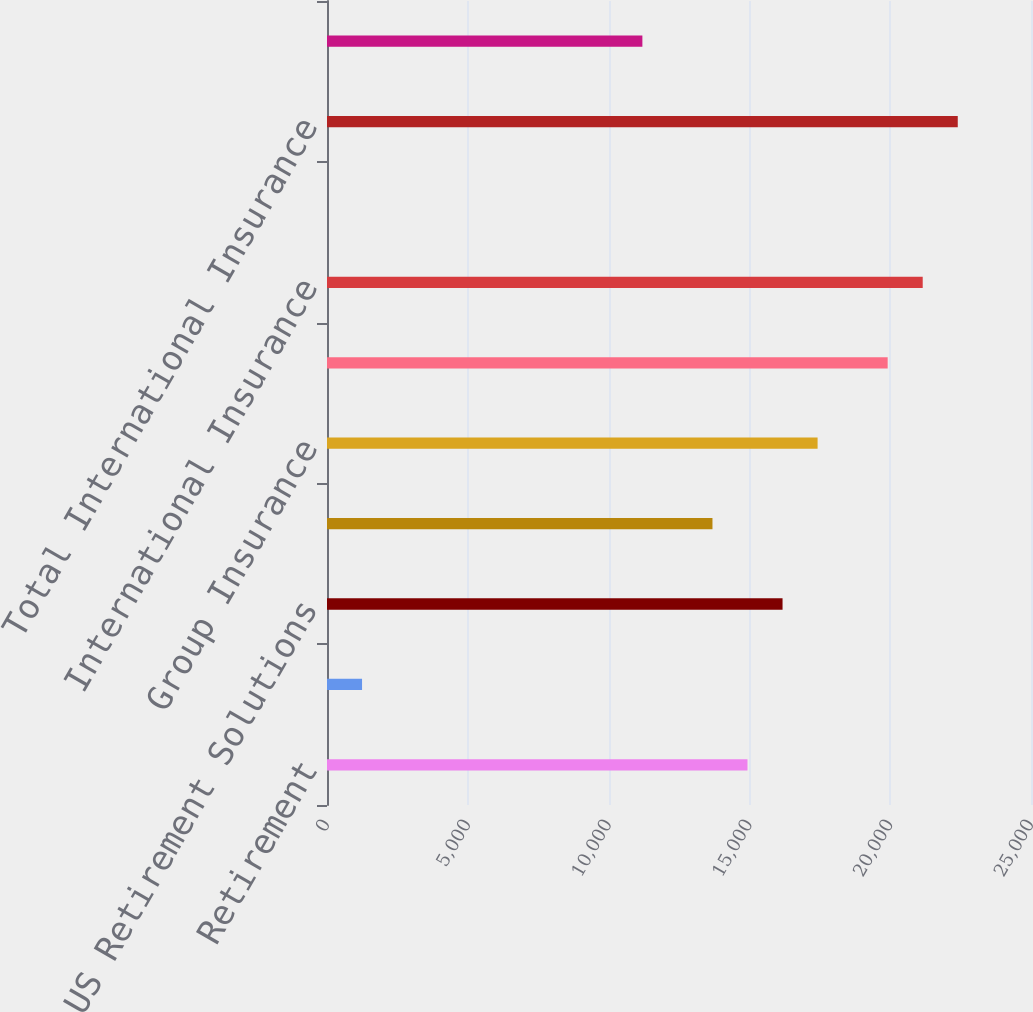Convert chart. <chart><loc_0><loc_0><loc_500><loc_500><bar_chart><fcel>Retirement<fcel>Asset Management<fcel>Total US Retirement Solutions<fcel>Individual Life<fcel>Group Insurance<fcel>Total US Individual Life and<fcel>International Insurance<fcel>International Investments<fcel>Total International Insurance<fcel>Corporate Operations<nl><fcel>14932.8<fcel>1244.61<fcel>16177.2<fcel>13688.4<fcel>17421.5<fcel>19910.3<fcel>21154.7<fcel>0.23<fcel>22399.1<fcel>11199.6<nl></chart> 